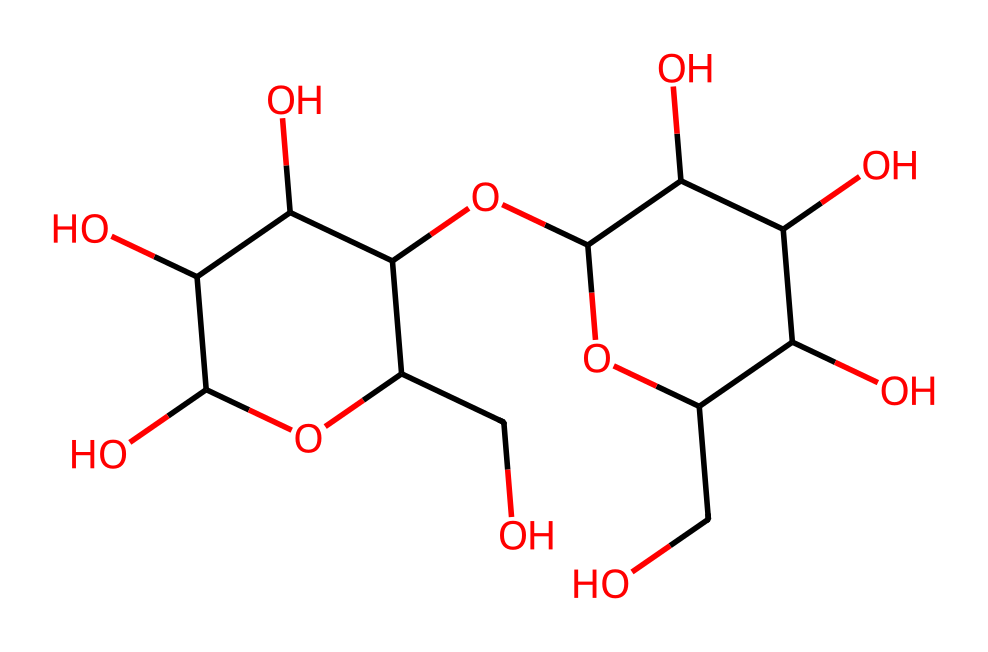What type of molecule is represented by this SMILES? This SMILES corresponds to a polysaccharide, specifically indicating a repetition of sugar units (most notably glucose) which are linked together. The multiple hydroxyl (-OH) groups also suggest the presence of cellulose, a common component in paper-making fibers.
Answer: polysaccharide How many carbon atoms does this molecule contain? By analyzing the SMILES structure, there are 12 carbon atoms present, which can be counted from the main chain and branching (denoted by 'C' in the SMILES).
Answer: 12 What functional groups are present in this chemical structure? The structure contains multiple hydroxyl (-OH) groups, which are indicative of alcohols, as well as ether groups (the oxygens connecting carbon chains). These functional groups are important for the chemical properties of cellulose.
Answer: hydroxyl, ether Is this molecule likely to be soluble in water? Yes, the presence of numerous hydroxyl groups makes this molecule highly polar, which generally allows for solubility in water due to hydrogen bonding capability.
Answer: Yes What role does this molecule play in the structure of paper? This molecule is a key structural component of cellulose, which provides strength and rigidity to paper fibers through extensive hydrogen bonding between chains.
Answer: structural component Why might this chemical have high tensile strength? The high tensile strength arises from the extensive hydrogen bonding between the hydroxyl groups of adjacent polymer chains, allowing for a strong interchain attraction and alignment of fibers.
Answer: hydrogen bonding What is the primary source of this molecule in nature? This molecule, similar to cellulose, primarily comes from plant cell walls, specifically trees and other woody plants, which are harvested for paper production.
Answer: plant cell walls 